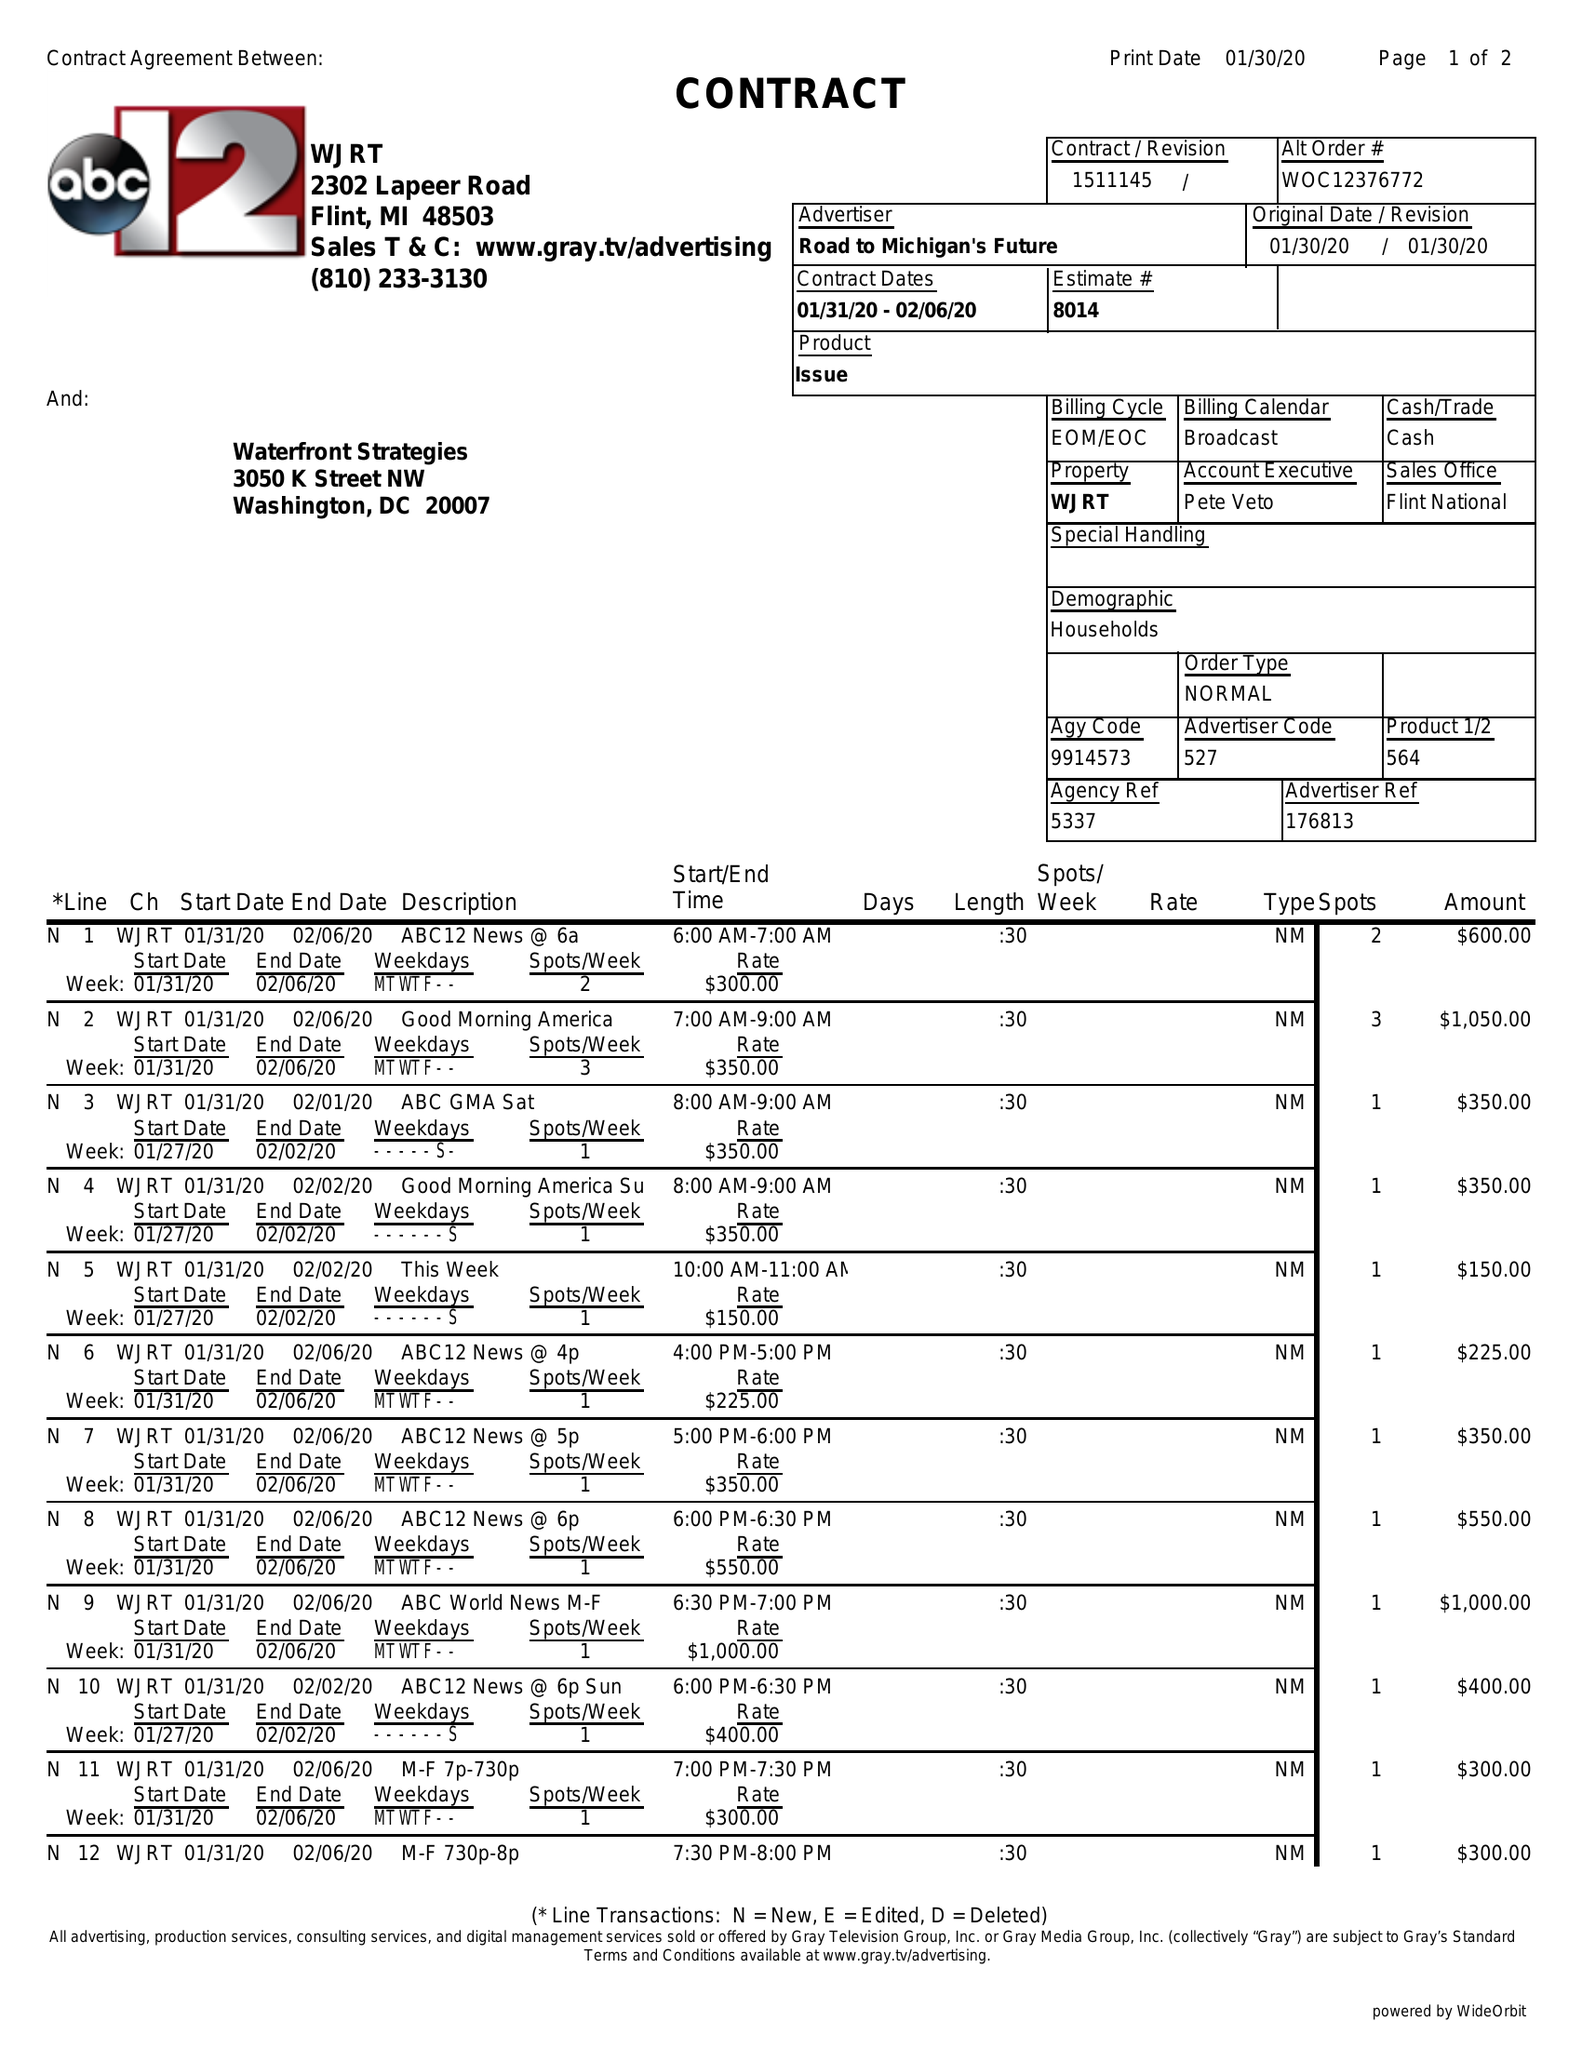What is the value for the gross_amount?
Answer the question using a single word or phrase. 6925.00 